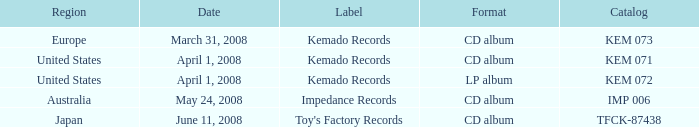Which Format has a Region of united states, and a Catalog of kem 072? LP album. Could you parse the entire table? {'header': ['Region', 'Date', 'Label', 'Format', 'Catalog'], 'rows': [['Europe', 'March 31, 2008', 'Kemado Records', 'CD album', 'KEM 073'], ['United States', 'April 1, 2008', 'Kemado Records', 'CD album', 'KEM 071'], ['United States', 'April 1, 2008', 'Kemado Records', 'LP album', 'KEM 072'], ['Australia', 'May 24, 2008', 'Impedance Records', 'CD album', 'IMP 006'], ['Japan', 'June 11, 2008', "Toy's Factory Records", 'CD album', 'TFCK-87438']]} 